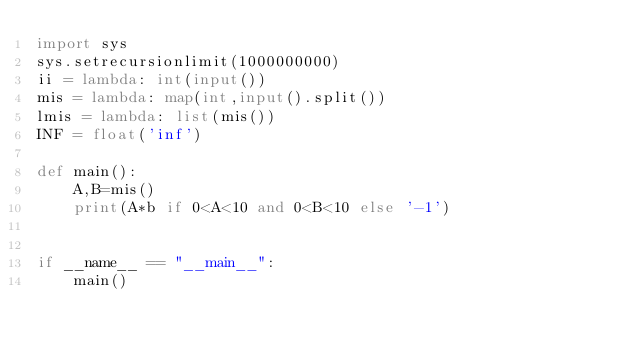Convert code to text. <code><loc_0><loc_0><loc_500><loc_500><_Python_>import sys
sys.setrecursionlimit(1000000000)
ii = lambda: int(input())
mis = lambda: map(int,input().split())
lmis = lambda: list(mis())
INF = float('inf')

def main():
    A,B=mis()
    print(A*b if 0<A<10 and 0<B<10 else '-1')


if __name__ == "__main__":
    main()</code> 